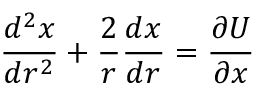<formula> <loc_0><loc_0><loc_500><loc_500>\frac { d ^ { 2 } x } { d r ^ { 2 } } + \frac { 2 } { r } \frac { d x } { d r } = \frac { \partial U } { \partial x }</formula> 